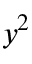Convert formula to latex. <formula><loc_0><loc_0><loc_500><loc_500>y ^ { 2 }</formula> 